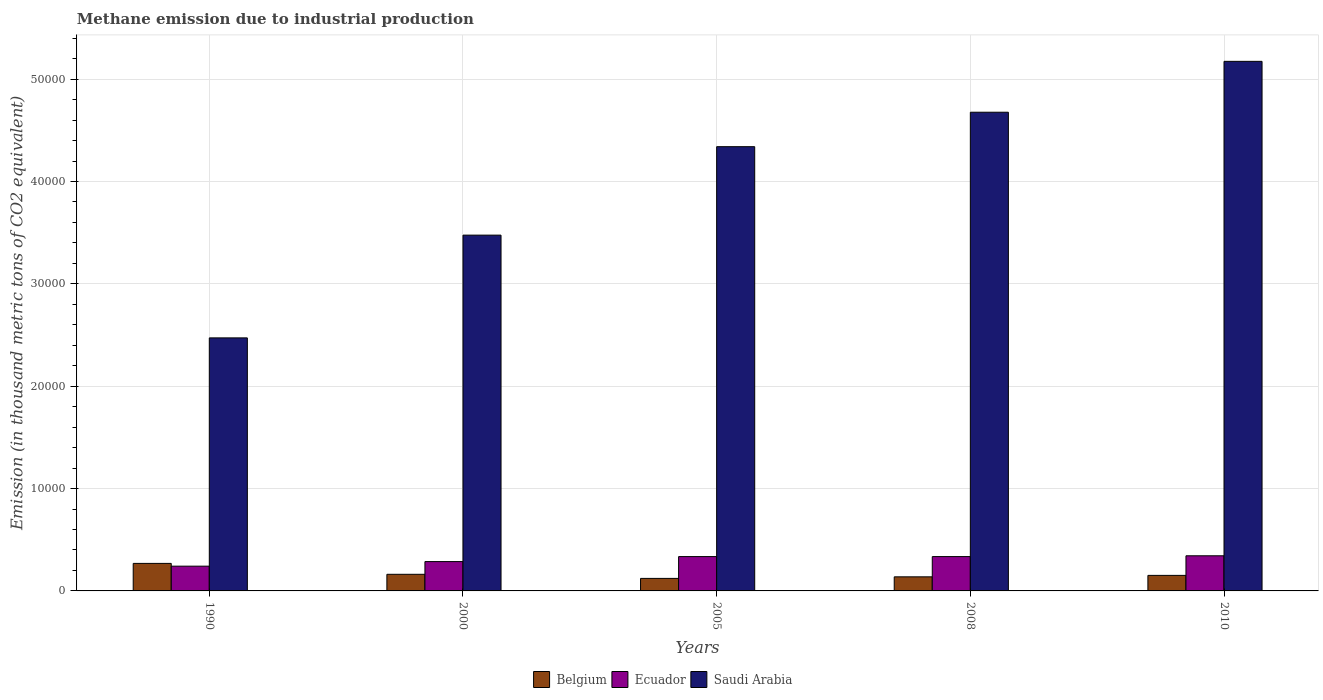Are the number of bars per tick equal to the number of legend labels?
Keep it short and to the point. Yes. How many bars are there on the 3rd tick from the left?
Your response must be concise. 3. What is the label of the 5th group of bars from the left?
Your answer should be very brief. 2010. What is the amount of methane emitted in Belgium in 2000?
Offer a very short reply. 1623. Across all years, what is the maximum amount of methane emitted in Ecuador?
Provide a short and direct response. 3432.8. Across all years, what is the minimum amount of methane emitted in Saudi Arabia?
Offer a terse response. 2.47e+04. In which year was the amount of methane emitted in Saudi Arabia minimum?
Ensure brevity in your answer.  1990. What is the total amount of methane emitted in Saudi Arabia in the graph?
Provide a succinct answer. 2.01e+05. What is the difference between the amount of methane emitted in Saudi Arabia in 1990 and that in 2000?
Keep it short and to the point. -1.00e+04. What is the difference between the amount of methane emitted in Saudi Arabia in 2010 and the amount of methane emitted in Ecuador in 1990?
Make the answer very short. 4.93e+04. What is the average amount of methane emitted in Ecuador per year?
Provide a succinct answer. 3085.26. In the year 1990, what is the difference between the amount of methane emitted in Belgium and amount of methane emitted in Ecuador?
Give a very brief answer. 269.8. In how many years, is the amount of methane emitted in Ecuador greater than 4000 thousand metric tons?
Your response must be concise. 0. What is the ratio of the amount of methane emitted in Belgium in 2005 to that in 2008?
Provide a succinct answer. 0.89. Is the difference between the amount of methane emitted in Belgium in 2005 and 2010 greater than the difference between the amount of methane emitted in Ecuador in 2005 and 2010?
Give a very brief answer. No. What is the difference between the highest and the second highest amount of methane emitted in Ecuador?
Provide a short and direct response. 78.1. What is the difference between the highest and the lowest amount of methane emitted in Belgium?
Offer a terse response. 1465.5. In how many years, is the amount of methane emitted in Belgium greater than the average amount of methane emitted in Belgium taken over all years?
Give a very brief answer. 1. What does the 3rd bar from the right in 2000 represents?
Provide a short and direct response. Belgium. How many years are there in the graph?
Offer a very short reply. 5. Does the graph contain any zero values?
Your answer should be compact. No. Does the graph contain grids?
Your answer should be compact. Yes. How are the legend labels stacked?
Give a very brief answer. Horizontal. What is the title of the graph?
Provide a short and direct response. Methane emission due to industrial production. Does "Belgium" appear as one of the legend labels in the graph?
Provide a succinct answer. Yes. What is the label or title of the Y-axis?
Your answer should be very brief. Emission (in thousand metric tons of CO2 equivalent). What is the Emission (in thousand metric tons of CO2 equivalent) in Belgium in 1990?
Provide a short and direct response. 2688.2. What is the Emission (in thousand metric tons of CO2 equivalent) of Ecuador in 1990?
Offer a terse response. 2418.4. What is the Emission (in thousand metric tons of CO2 equivalent) of Saudi Arabia in 1990?
Your response must be concise. 2.47e+04. What is the Emission (in thousand metric tons of CO2 equivalent) of Belgium in 2000?
Your answer should be compact. 1623. What is the Emission (in thousand metric tons of CO2 equivalent) in Ecuador in 2000?
Give a very brief answer. 2866.1. What is the Emission (in thousand metric tons of CO2 equivalent) in Saudi Arabia in 2000?
Keep it short and to the point. 3.48e+04. What is the Emission (in thousand metric tons of CO2 equivalent) of Belgium in 2005?
Your answer should be very brief. 1222.7. What is the Emission (in thousand metric tons of CO2 equivalent) in Ecuador in 2005?
Your answer should be very brief. 3354.7. What is the Emission (in thousand metric tons of CO2 equivalent) in Saudi Arabia in 2005?
Your answer should be very brief. 4.34e+04. What is the Emission (in thousand metric tons of CO2 equivalent) in Belgium in 2008?
Provide a short and direct response. 1376.4. What is the Emission (in thousand metric tons of CO2 equivalent) of Ecuador in 2008?
Make the answer very short. 3354.3. What is the Emission (in thousand metric tons of CO2 equivalent) in Saudi Arabia in 2008?
Keep it short and to the point. 4.68e+04. What is the Emission (in thousand metric tons of CO2 equivalent) in Belgium in 2010?
Offer a terse response. 1518. What is the Emission (in thousand metric tons of CO2 equivalent) of Ecuador in 2010?
Make the answer very short. 3432.8. What is the Emission (in thousand metric tons of CO2 equivalent) in Saudi Arabia in 2010?
Offer a terse response. 5.17e+04. Across all years, what is the maximum Emission (in thousand metric tons of CO2 equivalent) of Belgium?
Your answer should be compact. 2688.2. Across all years, what is the maximum Emission (in thousand metric tons of CO2 equivalent) of Ecuador?
Your answer should be compact. 3432.8. Across all years, what is the maximum Emission (in thousand metric tons of CO2 equivalent) in Saudi Arabia?
Your answer should be compact. 5.17e+04. Across all years, what is the minimum Emission (in thousand metric tons of CO2 equivalent) of Belgium?
Provide a succinct answer. 1222.7. Across all years, what is the minimum Emission (in thousand metric tons of CO2 equivalent) of Ecuador?
Your answer should be very brief. 2418.4. Across all years, what is the minimum Emission (in thousand metric tons of CO2 equivalent) of Saudi Arabia?
Provide a short and direct response. 2.47e+04. What is the total Emission (in thousand metric tons of CO2 equivalent) in Belgium in the graph?
Give a very brief answer. 8428.3. What is the total Emission (in thousand metric tons of CO2 equivalent) of Ecuador in the graph?
Make the answer very short. 1.54e+04. What is the total Emission (in thousand metric tons of CO2 equivalent) of Saudi Arabia in the graph?
Keep it short and to the point. 2.01e+05. What is the difference between the Emission (in thousand metric tons of CO2 equivalent) of Belgium in 1990 and that in 2000?
Your response must be concise. 1065.2. What is the difference between the Emission (in thousand metric tons of CO2 equivalent) of Ecuador in 1990 and that in 2000?
Your answer should be compact. -447.7. What is the difference between the Emission (in thousand metric tons of CO2 equivalent) of Saudi Arabia in 1990 and that in 2000?
Give a very brief answer. -1.00e+04. What is the difference between the Emission (in thousand metric tons of CO2 equivalent) in Belgium in 1990 and that in 2005?
Your answer should be very brief. 1465.5. What is the difference between the Emission (in thousand metric tons of CO2 equivalent) of Ecuador in 1990 and that in 2005?
Give a very brief answer. -936.3. What is the difference between the Emission (in thousand metric tons of CO2 equivalent) in Saudi Arabia in 1990 and that in 2005?
Your response must be concise. -1.87e+04. What is the difference between the Emission (in thousand metric tons of CO2 equivalent) in Belgium in 1990 and that in 2008?
Give a very brief answer. 1311.8. What is the difference between the Emission (in thousand metric tons of CO2 equivalent) of Ecuador in 1990 and that in 2008?
Your answer should be compact. -935.9. What is the difference between the Emission (in thousand metric tons of CO2 equivalent) in Saudi Arabia in 1990 and that in 2008?
Make the answer very short. -2.20e+04. What is the difference between the Emission (in thousand metric tons of CO2 equivalent) of Belgium in 1990 and that in 2010?
Your response must be concise. 1170.2. What is the difference between the Emission (in thousand metric tons of CO2 equivalent) of Ecuador in 1990 and that in 2010?
Offer a terse response. -1014.4. What is the difference between the Emission (in thousand metric tons of CO2 equivalent) of Saudi Arabia in 1990 and that in 2010?
Provide a succinct answer. -2.70e+04. What is the difference between the Emission (in thousand metric tons of CO2 equivalent) in Belgium in 2000 and that in 2005?
Offer a terse response. 400.3. What is the difference between the Emission (in thousand metric tons of CO2 equivalent) in Ecuador in 2000 and that in 2005?
Make the answer very short. -488.6. What is the difference between the Emission (in thousand metric tons of CO2 equivalent) in Saudi Arabia in 2000 and that in 2005?
Provide a short and direct response. -8641.3. What is the difference between the Emission (in thousand metric tons of CO2 equivalent) of Belgium in 2000 and that in 2008?
Provide a succinct answer. 246.6. What is the difference between the Emission (in thousand metric tons of CO2 equivalent) of Ecuador in 2000 and that in 2008?
Keep it short and to the point. -488.2. What is the difference between the Emission (in thousand metric tons of CO2 equivalent) in Saudi Arabia in 2000 and that in 2008?
Ensure brevity in your answer.  -1.20e+04. What is the difference between the Emission (in thousand metric tons of CO2 equivalent) in Belgium in 2000 and that in 2010?
Provide a succinct answer. 105. What is the difference between the Emission (in thousand metric tons of CO2 equivalent) in Ecuador in 2000 and that in 2010?
Offer a terse response. -566.7. What is the difference between the Emission (in thousand metric tons of CO2 equivalent) of Saudi Arabia in 2000 and that in 2010?
Offer a terse response. -1.70e+04. What is the difference between the Emission (in thousand metric tons of CO2 equivalent) in Belgium in 2005 and that in 2008?
Keep it short and to the point. -153.7. What is the difference between the Emission (in thousand metric tons of CO2 equivalent) in Ecuador in 2005 and that in 2008?
Provide a succinct answer. 0.4. What is the difference between the Emission (in thousand metric tons of CO2 equivalent) in Saudi Arabia in 2005 and that in 2008?
Provide a succinct answer. -3365.4. What is the difference between the Emission (in thousand metric tons of CO2 equivalent) in Belgium in 2005 and that in 2010?
Ensure brevity in your answer.  -295.3. What is the difference between the Emission (in thousand metric tons of CO2 equivalent) of Ecuador in 2005 and that in 2010?
Your response must be concise. -78.1. What is the difference between the Emission (in thousand metric tons of CO2 equivalent) of Saudi Arabia in 2005 and that in 2010?
Provide a short and direct response. -8336. What is the difference between the Emission (in thousand metric tons of CO2 equivalent) in Belgium in 2008 and that in 2010?
Keep it short and to the point. -141.6. What is the difference between the Emission (in thousand metric tons of CO2 equivalent) in Ecuador in 2008 and that in 2010?
Provide a succinct answer. -78.5. What is the difference between the Emission (in thousand metric tons of CO2 equivalent) of Saudi Arabia in 2008 and that in 2010?
Your answer should be compact. -4970.6. What is the difference between the Emission (in thousand metric tons of CO2 equivalent) in Belgium in 1990 and the Emission (in thousand metric tons of CO2 equivalent) in Ecuador in 2000?
Keep it short and to the point. -177.9. What is the difference between the Emission (in thousand metric tons of CO2 equivalent) in Belgium in 1990 and the Emission (in thousand metric tons of CO2 equivalent) in Saudi Arabia in 2000?
Your response must be concise. -3.21e+04. What is the difference between the Emission (in thousand metric tons of CO2 equivalent) of Ecuador in 1990 and the Emission (in thousand metric tons of CO2 equivalent) of Saudi Arabia in 2000?
Offer a terse response. -3.23e+04. What is the difference between the Emission (in thousand metric tons of CO2 equivalent) in Belgium in 1990 and the Emission (in thousand metric tons of CO2 equivalent) in Ecuador in 2005?
Provide a succinct answer. -666.5. What is the difference between the Emission (in thousand metric tons of CO2 equivalent) of Belgium in 1990 and the Emission (in thousand metric tons of CO2 equivalent) of Saudi Arabia in 2005?
Your answer should be very brief. -4.07e+04. What is the difference between the Emission (in thousand metric tons of CO2 equivalent) of Ecuador in 1990 and the Emission (in thousand metric tons of CO2 equivalent) of Saudi Arabia in 2005?
Offer a very short reply. -4.10e+04. What is the difference between the Emission (in thousand metric tons of CO2 equivalent) of Belgium in 1990 and the Emission (in thousand metric tons of CO2 equivalent) of Ecuador in 2008?
Ensure brevity in your answer.  -666.1. What is the difference between the Emission (in thousand metric tons of CO2 equivalent) in Belgium in 1990 and the Emission (in thousand metric tons of CO2 equivalent) in Saudi Arabia in 2008?
Your response must be concise. -4.41e+04. What is the difference between the Emission (in thousand metric tons of CO2 equivalent) in Ecuador in 1990 and the Emission (in thousand metric tons of CO2 equivalent) in Saudi Arabia in 2008?
Make the answer very short. -4.43e+04. What is the difference between the Emission (in thousand metric tons of CO2 equivalent) of Belgium in 1990 and the Emission (in thousand metric tons of CO2 equivalent) of Ecuador in 2010?
Give a very brief answer. -744.6. What is the difference between the Emission (in thousand metric tons of CO2 equivalent) in Belgium in 1990 and the Emission (in thousand metric tons of CO2 equivalent) in Saudi Arabia in 2010?
Make the answer very short. -4.90e+04. What is the difference between the Emission (in thousand metric tons of CO2 equivalent) of Ecuador in 1990 and the Emission (in thousand metric tons of CO2 equivalent) of Saudi Arabia in 2010?
Give a very brief answer. -4.93e+04. What is the difference between the Emission (in thousand metric tons of CO2 equivalent) of Belgium in 2000 and the Emission (in thousand metric tons of CO2 equivalent) of Ecuador in 2005?
Keep it short and to the point. -1731.7. What is the difference between the Emission (in thousand metric tons of CO2 equivalent) of Belgium in 2000 and the Emission (in thousand metric tons of CO2 equivalent) of Saudi Arabia in 2005?
Offer a very short reply. -4.18e+04. What is the difference between the Emission (in thousand metric tons of CO2 equivalent) of Ecuador in 2000 and the Emission (in thousand metric tons of CO2 equivalent) of Saudi Arabia in 2005?
Ensure brevity in your answer.  -4.05e+04. What is the difference between the Emission (in thousand metric tons of CO2 equivalent) in Belgium in 2000 and the Emission (in thousand metric tons of CO2 equivalent) in Ecuador in 2008?
Give a very brief answer. -1731.3. What is the difference between the Emission (in thousand metric tons of CO2 equivalent) of Belgium in 2000 and the Emission (in thousand metric tons of CO2 equivalent) of Saudi Arabia in 2008?
Your answer should be very brief. -4.51e+04. What is the difference between the Emission (in thousand metric tons of CO2 equivalent) in Ecuador in 2000 and the Emission (in thousand metric tons of CO2 equivalent) in Saudi Arabia in 2008?
Keep it short and to the point. -4.39e+04. What is the difference between the Emission (in thousand metric tons of CO2 equivalent) in Belgium in 2000 and the Emission (in thousand metric tons of CO2 equivalent) in Ecuador in 2010?
Offer a terse response. -1809.8. What is the difference between the Emission (in thousand metric tons of CO2 equivalent) of Belgium in 2000 and the Emission (in thousand metric tons of CO2 equivalent) of Saudi Arabia in 2010?
Give a very brief answer. -5.01e+04. What is the difference between the Emission (in thousand metric tons of CO2 equivalent) of Ecuador in 2000 and the Emission (in thousand metric tons of CO2 equivalent) of Saudi Arabia in 2010?
Your response must be concise. -4.89e+04. What is the difference between the Emission (in thousand metric tons of CO2 equivalent) in Belgium in 2005 and the Emission (in thousand metric tons of CO2 equivalent) in Ecuador in 2008?
Keep it short and to the point. -2131.6. What is the difference between the Emission (in thousand metric tons of CO2 equivalent) in Belgium in 2005 and the Emission (in thousand metric tons of CO2 equivalent) in Saudi Arabia in 2008?
Your answer should be compact. -4.55e+04. What is the difference between the Emission (in thousand metric tons of CO2 equivalent) of Ecuador in 2005 and the Emission (in thousand metric tons of CO2 equivalent) of Saudi Arabia in 2008?
Give a very brief answer. -4.34e+04. What is the difference between the Emission (in thousand metric tons of CO2 equivalent) in Belgium in 2005 and the Emission (in thousand metric tons of CO2 equivalent) in Ecuador in 2010?
Your answer should be compact. -2210.1. What is the difference between the Emission (in thousand metric tons of CO2 equivalent) in Belgium in 2005 and the Emission (in thousand metric tons of CO2 equivalent) in Saudi Arabia in 2010?
Your response must be concise. -5.05e+04. What is the difference between the Emission (in thousand metric tons of CO2 equivalent) of Ecuador in 2005 and the Emission (in thousand metric tons of CO2 equivalent) of Saudi Arabia in 2010?
Make the answer very short. -4.84e+04. What is the difference between the Emission (in thousand metric tons of CO2 equivalent) of Belgium in 2008 and the Emission (in thousand metric tons of CO2 equivalent) of Ecuador in 2010?
Your answer should be very brief. -2056.4. What is the difference between the Emission (in thousand metric tons of CO2 equivalent) of Belgium in 2008 and the Emission (in thousand metric tons of CO2 equivalent) of Saudi Arabia in 2010?
Keep it short and to the point. -5.04e+04. What is the difference between the Emission (in thousand metric tons of CO2 equivalent) of Ecuador in 2008 and the Emission (in thousand metric tons of CO2 equivalent) of Saudi Arabia in 2010?
Offer a very short reply. -4.84e+04. What is the average Emission (in thousand metric tons of CO2 equivalent) in Belgium per year?
Provide a short and direct response. 1685.66. What is the average Emission (in thousand metric tons of CO2 equivalent) in Ecuador per year?
Your response must be concise. 3085.26. What is the average Emission (in thousand metric tons of CO2 equivalent) in Saudi Arabia per year?
Offer a very short reply. 4.03e+04. In the year 1990, what is the difference between the Emission (in thousand metric tons of CO2 equivalent) of Belgium and Emission (in thousand metric tons of CO2 equivalent) of Ecuador?
Offer a terse response. 269.8. In the year 1990, what is the difference between the Emission (in thousand metric tons of CO2 equivalent) of Belgium and Emission (in thousand metric tons of CO2 equivalent) of Saudi Arabia?
Offer a terse response. -2.20e+04. In the year 1990, what is the difference between the Emission (in thousand metric tons of CO2 equivalent) in Ecuador and Emission (in thousand metric tons of CO2 equivalent) in Saudi Arabia?
Offer a very short reply. -2.23e+04. In the year 2000, what is the difference between the Emission (in thousand metric tons of CO2 equivalent) in Belgium and Emission (in thousand metric tons of CO2 equivalent) in Ecuador?
Provide a succinct answer. -1243.1. In the year 2000, what is the difference between the Emission (in thousand metric tons of CO2 equivalent) of Belgium and Emission (in thousand metric tons of CO2 equivalent) of Saudi Arabia?
Give a very brief answer. -3.31e+04. In the year 2000, what is the difference between the Emission (in thousand metric tons of CO2 equivalent) of Ecuador and Emission (in thousand metric tons of CO2 equivalent) of Saudi Arabia?
Your response must be concise. -3.19e+04. In the year 2005, what is the difference between the Emission (in thousand metric tons of CO2 equivalent) of Belgium and Emission (in thousand metric tons of CO2 equivalent) of Ecuador?
Make the answer very short. -2132. In the year 2005, what is the difference between the Emission (in thousand metric tons of CO2 equivalent) in Belgium and Emission (in thousand metric tons of CO2 equivalent) in Saudi Arabia?
Provide a succinct answer. -4.22e+04. In the year 2005, what is the difference between the Emission (in thousand metric tons of CO2 equivalent) in Ecuador and Emission (in thousand metric tons of CO2 equivalent) in Saudi Arabia?
Ensure brevity in your answer.  -4.00e+04. In the year 2008, what is the difference between the Emission (in thousand metric tons of CO2 equivalent) of Belgium and Emission (in thousand metric tons of CO2 equivalent) of Ecuador?
Offer a very short reply. -1977.9. In the year 2008, what is the difference between the Emission (in thousand metric tons of CO2 equivalent) of Belgium and Emission (in thousand metric tons of CO2 equivalent) of Saudi Arabia?
Your answer should be compact. -4.54e+04. In the year 2008, what is the difference between the Emission (in thousand metric tons of CO2 equivalent) of Ecuador and Emission (in thousand metric tons of CO2 equivalent) of Saudi Arabia?
Make the answer very short. -4.34e+04. In the year 2010, what is the difference between the Emission (in thousand metric tons of CO2 equivalent) in Belgium and Emission (in thousand metric tons of CO2 equivalent) in Ecuador?
Your response must be concise. -1914.8. In the year 2010, what is the difference between the Emission (in thousand metric tons of CO2 equivalent) in Belgium and Emission (in thousand metric tons of CO2 equivalent) in Saudi Arabia?
Keep it short and to the point. -5.02e+04. In the year 2010, what is the difference between the Emission (in thousand metric tons of CO2 equivalent) of Ecuador and Emission (in thousand metric tons of CO2 equivalent) of Saudi Arabia?
Provide a succinct answer. -4.83e+04. What is the ratio of the Emission (in thousand metric tons of CO2 equivalent) of Belgium in 1990 to that in 2000?
Offer a very short reply. 1.66. What is the ratio of the Emission (in thousand metric tons of CO2 equivalent) in Ecuador in 1990 to that in 2000?
Give a very brief answer. 0.84. What is the ratio of the Emission (in thousand metric tons of CO2 equivalent) in Saudi Arabia in 1990 to that in 2000?
Your answer should be compact. 0.71. What is the ratio of the Emission (in thousand metric tons of CO2 equivalent) in Belgium in 1990 to that in 2005?
Your answer should be compact. 2.2. What is the ratio of the Emission (in thousand metric tons of CO2 equivalent) in Ecuador in 1990 to that in 2005?
Your answer should be compact. 0.72. What is the ratio of the Emission (in thousand metric tons of CO2 equivalent) in Saudi Arabia in 1990 to that in 2005?
Make the answer very short. 0.57. What is the ratio of the Emission (in thousand metric tons of CO2 equivalent) of Belgium in 1990 to that in 2008?
Your response must be concise. 1.95. What is the ratio of the Emission (in thousand metric tons of CO2 equivalent) in Ecuador in 1990 to that in 2008?
Ensure brevity in your answer.  0.72. What is the ratio of the Emission (in thousand metric tons of CO2 equivalent) of Saudi Arabia in 1990 to that in 2008?
Provide a short and direct response. 0.53. What is the ratio of the Emission (in thousand metric tons of CO2 equivalent) in Belgium in 1990 to that in 2010?
Your response must be concise. 1.77. What is the ratio of the Emission (in thousand metric tons of CO2 equivalent) of Ecuador in 1990 to that in 2010?
Your answer should be compact. 0.7. What is the ratio of the Emission (in thousand metric tons of CO2 equivalent) of Saudi Arabia in 1990 to that in 2010?
Keep it short and to the point. 0.48. What is the ratio of the Emission (in thousand metric tons of CO2 equivalent) of Belgium in 2000 to that in 2005?
Your response must be concise. 1.33. What is the ratio of the Emission (in thousand metric tons of CO2 equivalent) of Ecuador in 2000 to that in 2005?
Give a very brief answer. 0.85. What is the ratio of the Emission (in thousand metric tons of CO2 equivalent) in Saudi Arabia in 2000 to that in 2005?
Your answer should be compact. 0.8. What is the ratio of the Emission (in thousand metric tons of CO2 equivalent) in Belgium in 2000 to that in 2008?
Provide a succinct answer. 1.18. What is the ratio of the Emission (in thousand metric tons of CO2 equivalent) in Ecuador in 2000 to that in 2008?
Keep it short and to the point. 0.85. What is the ratio of the Emission (in thousand metric tons of CO2 equivalent) in Saudi Arabia in 2000 to that in 2008?
Keep it short and to the point. 0.74. What is the ratio of the Emission (in thousand metric tons of CO2 equivalent) of Belgium in 2000 to that in 2010?
Your answer should be compact. 1.07. What is the ratio of the Emission (in thousand metric tons of CO2 equivalent) in Ecuador in 2000 to that in 2010?
Ensure brevity in your answer.  0.83. What is the ratio of the Emission (in thousand metric tons of CO2 equivalent) of Saudi Arabia in 2000 to that in 2010?
Ensure brevity in your answer.  0.67. What is the ratio of the Emission (in thousand metric tons of CO2 equivalent) of Belgium in 2005 to that in 2008?
Offer a terse response. 0.89. What is the ratio of the Emission (in thousand metric tons of CO2 equivalent) in Ecuador in 2005 to that in 2008?
Provide a succinct answer. 1. What is the ratio of the Emission (in thousand metric tons of CO2 equivalent) in Saudi Arabia in 2005 to that in 2008?
Offer a very short reply. 0.93. What is the ratio of the Emission (in thousand metric tons of CO2 equivalent) in Belgium in 2005 to that in 2010?
Ensure brevity in your answer.  0.81. What is the ratio of the Emission (in thousand metric tons of CO2 equivalent) in Ecuador in 2005 to that in 2010?
Your response must be concise. 0.98. What is the ratio of the Emission (in thousand metric tons of CO2 equivalent) in Saudi Arabia in 2005 to that in 2010?
Your response must be concise. 0.84. What is the ratio of the Emission (in thousand metric tons of CO2 equivalent) in Belgium in 2008 to that in 2010?
Provide a short and direct response. 0.91. What is the ratio of the Emission (in thousand metric tons of CO2 equivalent) in Ecuador in 2008 to that in 2010?
Your answer should be very brief. 0.98. What is the ratio of the Emission (in thousand metric tons of CO2 equivalent) of Saudi Arabia in 2008 to that in 2010?
Give a very brief answer. 0.9. What is the difference between the highest and the second highest Emission (in thousand metric tons of CO2 equivalent) of Belgium?
Your answer should be very brief. 1065.2. What is the difference between the highest and the second highest Emission (in thousand metric tons of CO2 equivalent) of Ecuador?
Your response must be concise. 78.1. What is the difference between the highest and the second highest Emission (in thousand metric tons of CO2 equivalent) of Saudi Arabia?
Offer a terse response. 4970.6. What is the difference between the highest and the lowest Emission (in thousand metric tons of CO2 equivalent) in Belgium?
Provide a short and direct response. 1465.5. What is the difference between the highest and the lowest Emission (in thousand metric tons of CO2 equivalent) in Ecuador?
Offer a very short reply. 1014.4. What is the difference between the highest and the lowest Emission (in thousand metric tons of CO2 equivalent) of Saudi Arabia?
Your answer should be compact. 2.70e+04. 